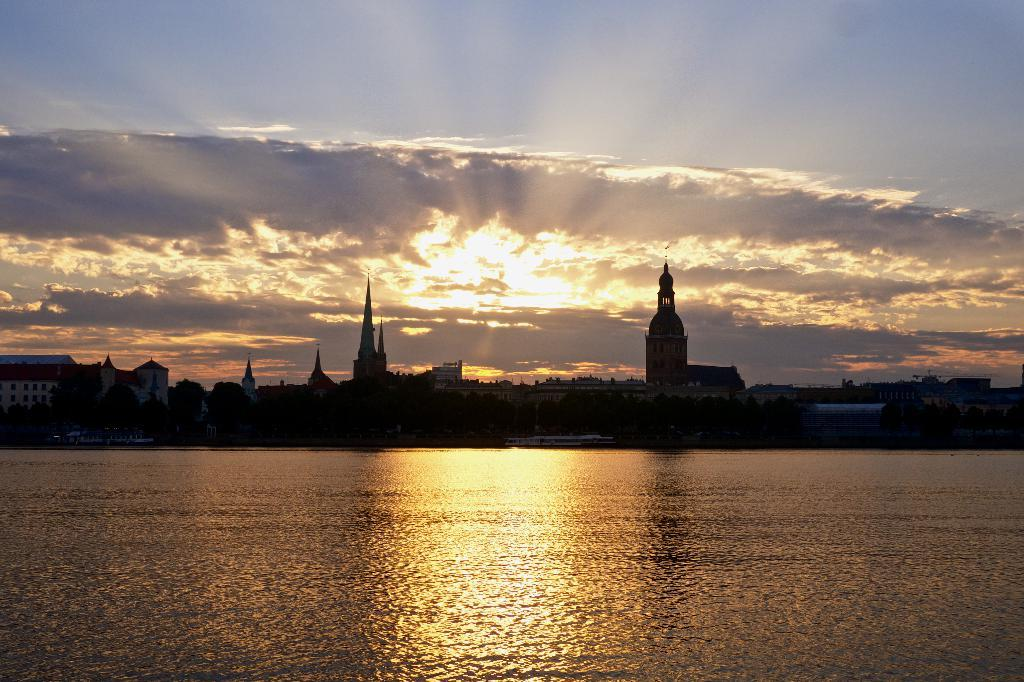What is the main feature of the image that is covered by water? There is water covering a place in the image. What type of structures can be seen on the ground in the image? Buildings and houses are present on the ground in the image. What can be seen in the sky in the image? The sky is visible in the image, and the sun and clouds are present. What is the price of the things that are floating in the water in the image? There are no things floating in the water in the image; it only shows water covering a place. 